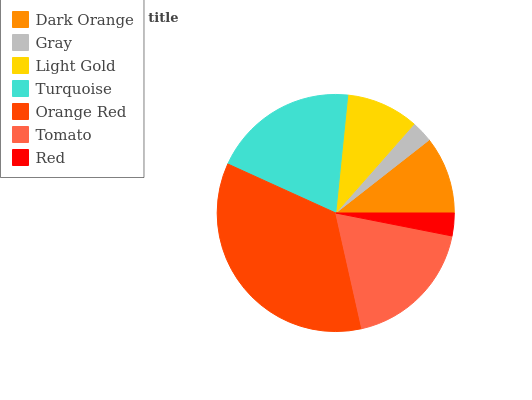Is Gray the minimum?
Answer yes or no. Yes. Is Orange Red the maximum?
Answer yes or no. Yes. Is Light Gold the minimum?
Answer yes or no. No. Is Light Gold the maximum?
Answer yes or no. No. Is Light Gold greater than Gray?
Answer yes or no. Yes. Is Gray less than Light Gold?
Answer yes or no. Yes. Is Gray greater than Light Gold?
Answer yes or no. No. Is Light Gold less than Gray?
Answer yes or no. No. Is Dark Orange the high median?
Answer yes or no. Yes. Is Dark Orange the low median?
Answer yes or no. Yes. Is Red the high median?
Answer yes or no. No. Is Turquoise the low median?
Answer yes or no. No. 